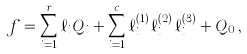<formula> <loc_0><loc_0><loc_500><loc_500>f = \sum _ { i = 1 } ^ { r } \ell _ { i } Q _ { i } + \sum _ { i = 1 } ^ { c } \ell _ { i } ^ { ( 1 ) } \ell _ { i } ^ { ( 2 ) } \ell _ { i } ^ { ( 3 ) } + Q _ { 0 } \, ,</formula> 